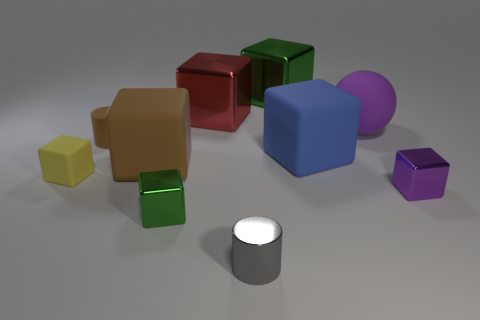Which object stands out the most due to its size? The blue cube is the largest object and stands out due to its size compared to the other shapes in the image. 